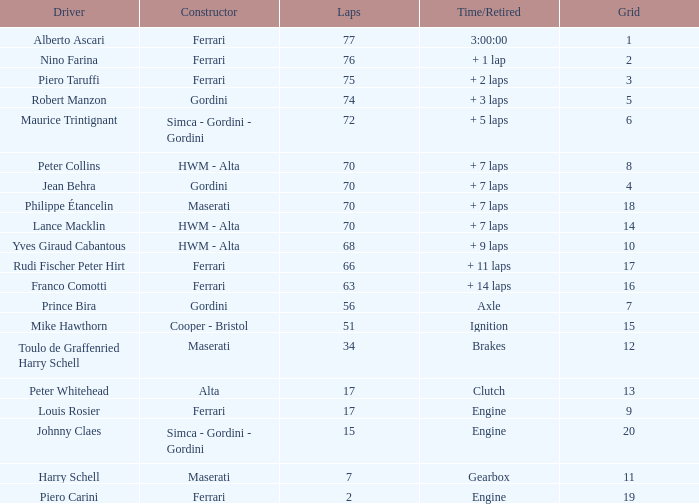Who drove the car with over 66 laps with a grid of 5? Robert Manzon. 